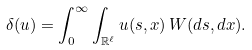<formula> <loc_0><loc_0><loc_500><loc_500>\delta ( u ) = \int _ { 0 } ^ { \infty } \int _ { \mathbb { R } ^ { \ell } } u ( s , x ) \, W ( d s , d x ) .</formula> 